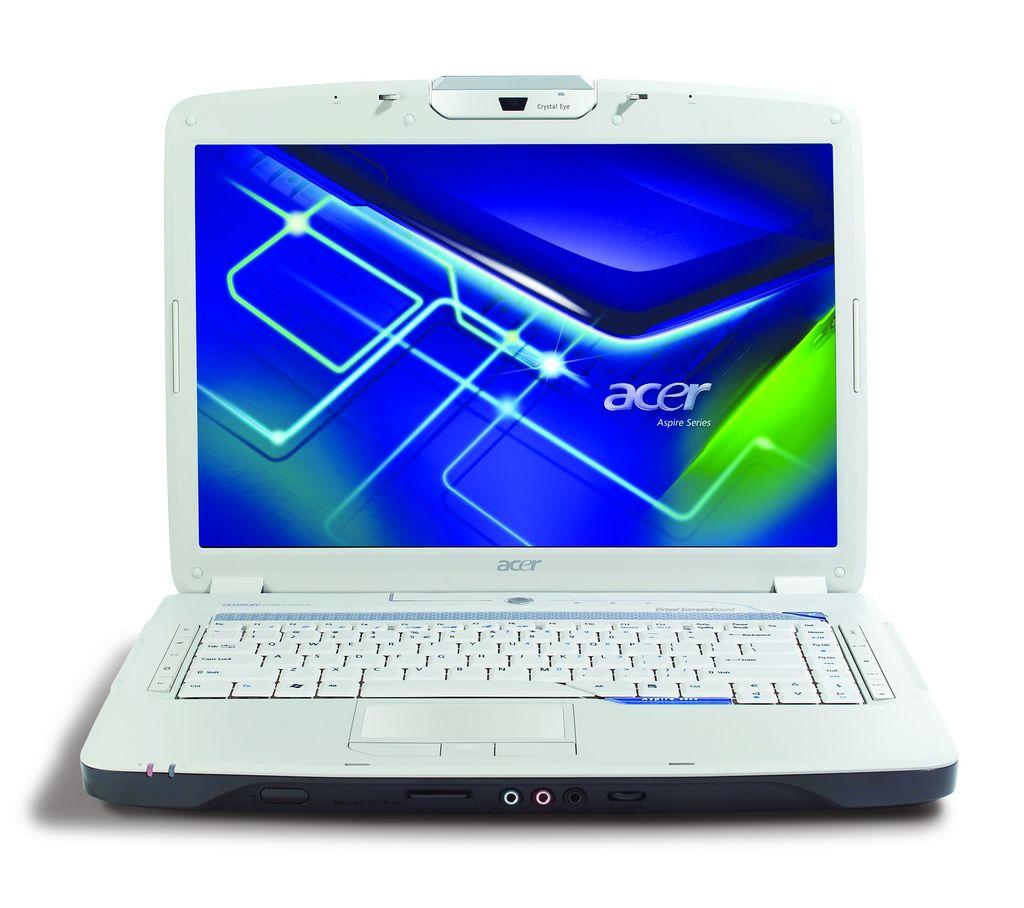What brand of laptop is this?
Offer a very short reply. Acer. What is the web camera called on the laptop?
Your answer should be very brief. Crystal eye. 